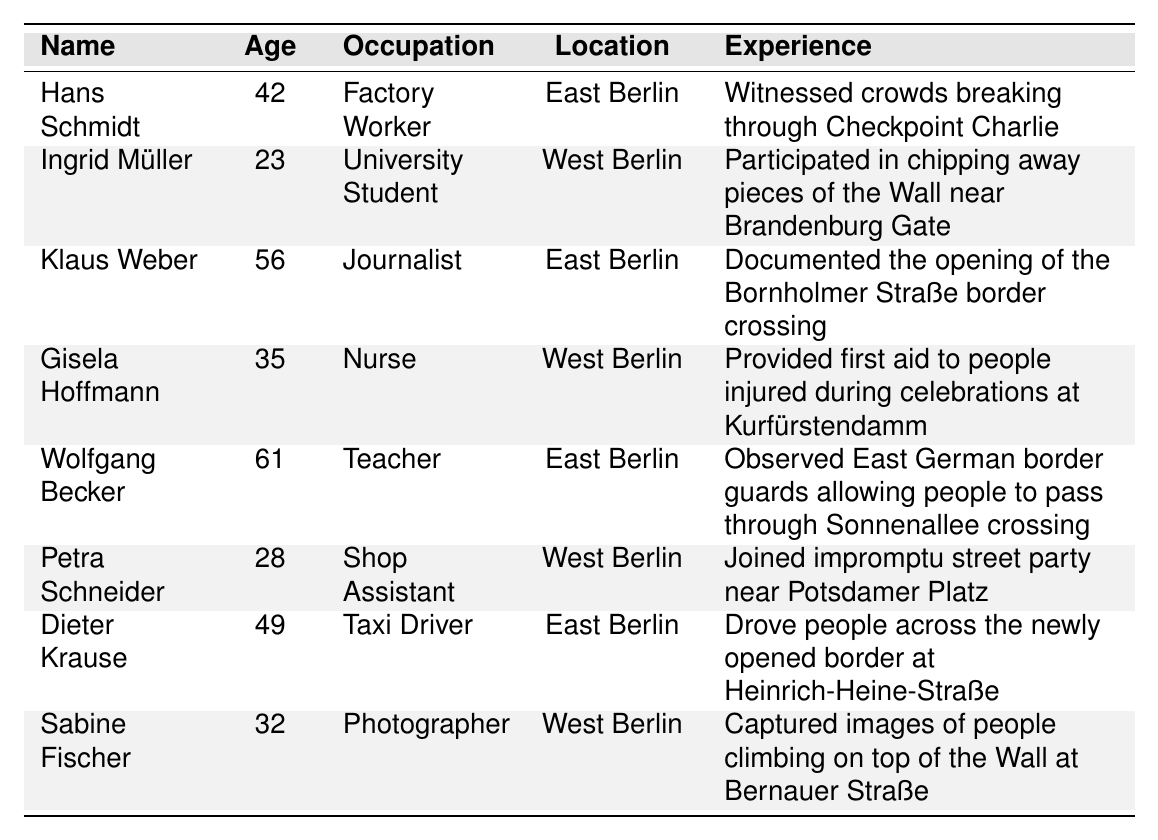What is the occupation of Hans Schmidt? The table lists Hans Schmidt as a Factory Worker under the Occupation column.
Answer: Factory Worker How old is Ingrid Müller? The table states that Ingrid Müller is 23 years old in the Age column.
Answer: 23 Which eyewitness account involves a first aid experience? Gisela Hoffmann's experience involves providing first aid to people injured during the celebrations at Kurfürstendamm, as per the Experience column.
Answer: Gisela Hoffmann What was Klaus Weber's experience during the fall of the Berlin Wall? According to the Experience column, Klaus Weber documented the opening of the Bornholmer Straße border crossing.
Answer: Documented the opening of the Bornholmer Straße border crossing How many eyewitness accounts are from East Berlin? There are four accounts from East Berlin (Hans Schmidt, Klaus Weber, Wolfgang Becker, Dieter Krause) based on the Location column.
Answer: 4 What is the average age of the eyewitnesses? The ages of the eyewitnesses are 42, 23, 56, 35, 61, 28, 49, and 32, which sum up to 326. Dividing by 8 gives an average age of 40.75.
Answer: 40.75 Is there an eyewitness with the occupation of a Tax Driver? The table includes Dieter Krause as a Taxi Driver in the Occupation column.
Answer: Yes Who is the youngest eyewitness, and what is their experience? Ingrid Müller is the youngest at 23 years old, and she participated in chipping away pieces of the Wall near Brandenburg Gate according to the Experience column.
Answer: Ingrid Müller, participated in chipping away pieces of the Wall near Brandenburg Gate Which witness provided aid to people during the celebrations? Gisela Hoffmann provided first aid to people injured during the celebrations as noted in the Experience column.
Answer: Gisela Hoffmann How many eyewitness accounts list occupations related to education or healthcare? The table shows two accounts related to education or healthcare: Klaus Weber (Journalist) and Gisela Hoffmann (Nurse), making a total of 2.
Answer: 2 